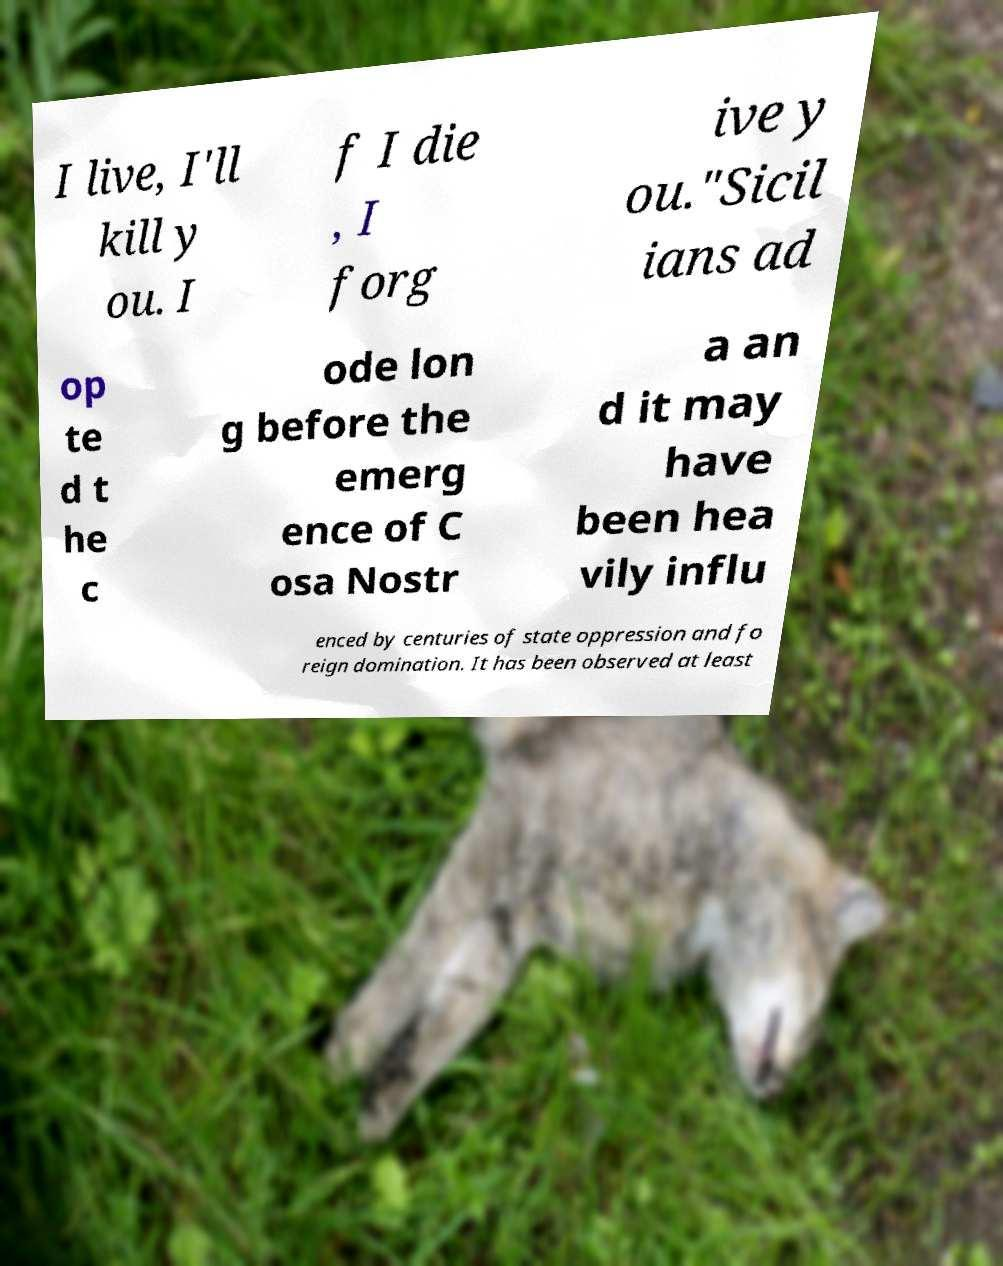Please read and relay the text visible in this image. What does it say? I live, I'll kill y ou. I f I die , I forg ive y ou."Sicil ians ad op te d t he c ode lon g before the emerg ence of C osa Nostr a an d it may have been hea vily influ enced by centuries of state oppression and fo reign domination. It has been observed at least 